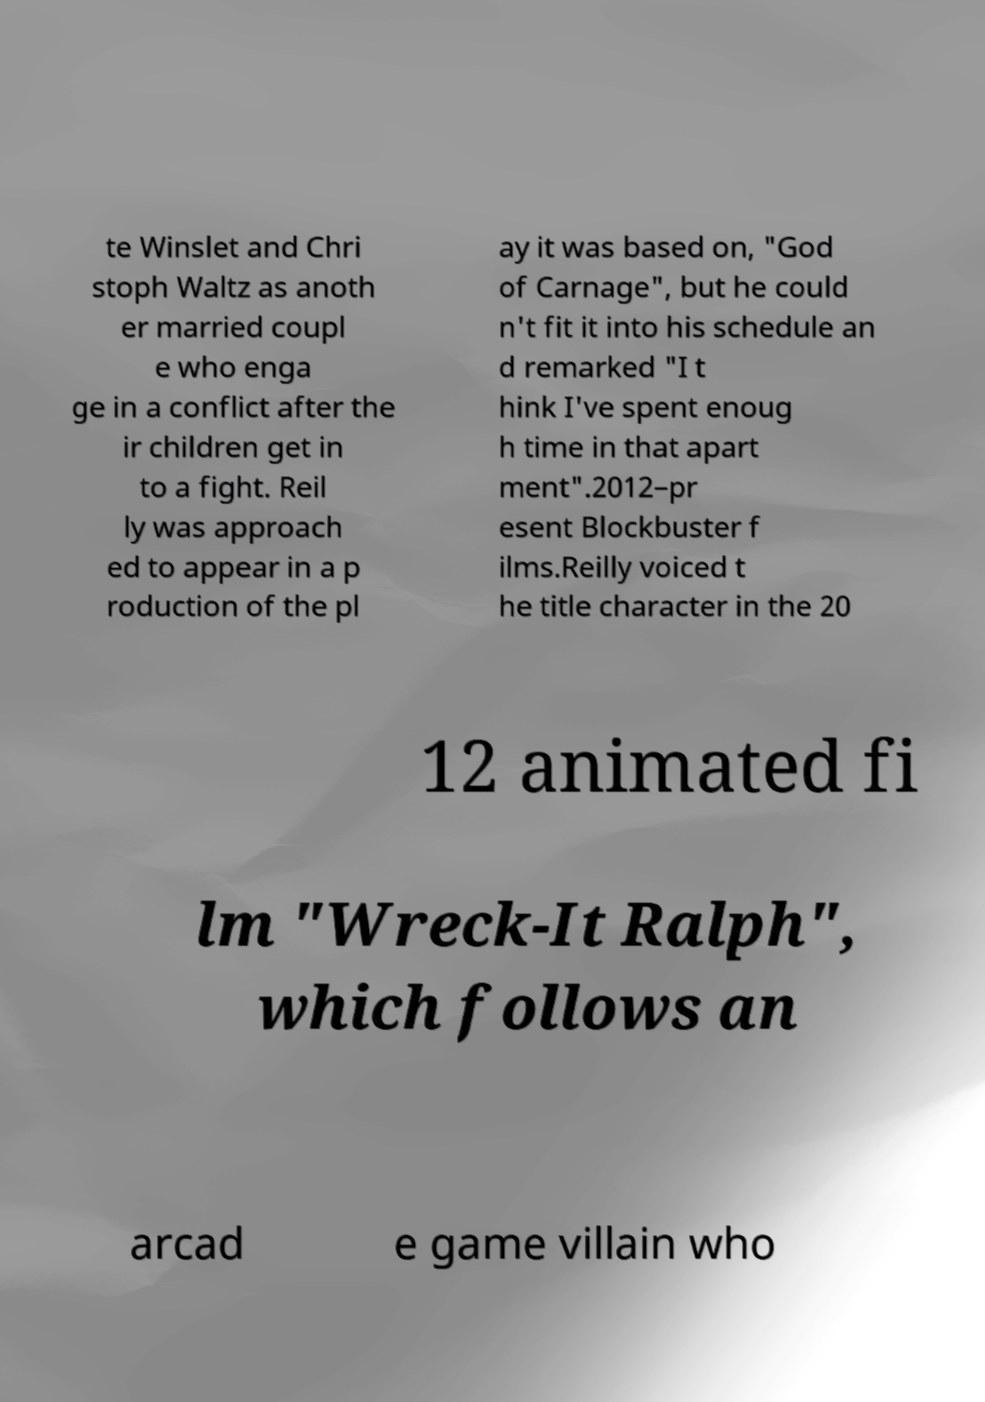Could you extract and type out the text from this image? te Winslet and Chri stoph Waltz as anoth er married coupl e who enga ge in a conflict after the ir children get in to a fight. Reil ly was approach ed to appear in a p roduction of the pl ay it was based on, "God of Carnage", but he could n't fit it into his schedule an d remarked "I t hink I've spent enoug h time in that apart ment".2012–pr esent Blockbuster f ilms.Reilly voiced t he title character in the 20 12 animated fi lm "Wreck-It Ralph", which follows an arcad e game villain who 